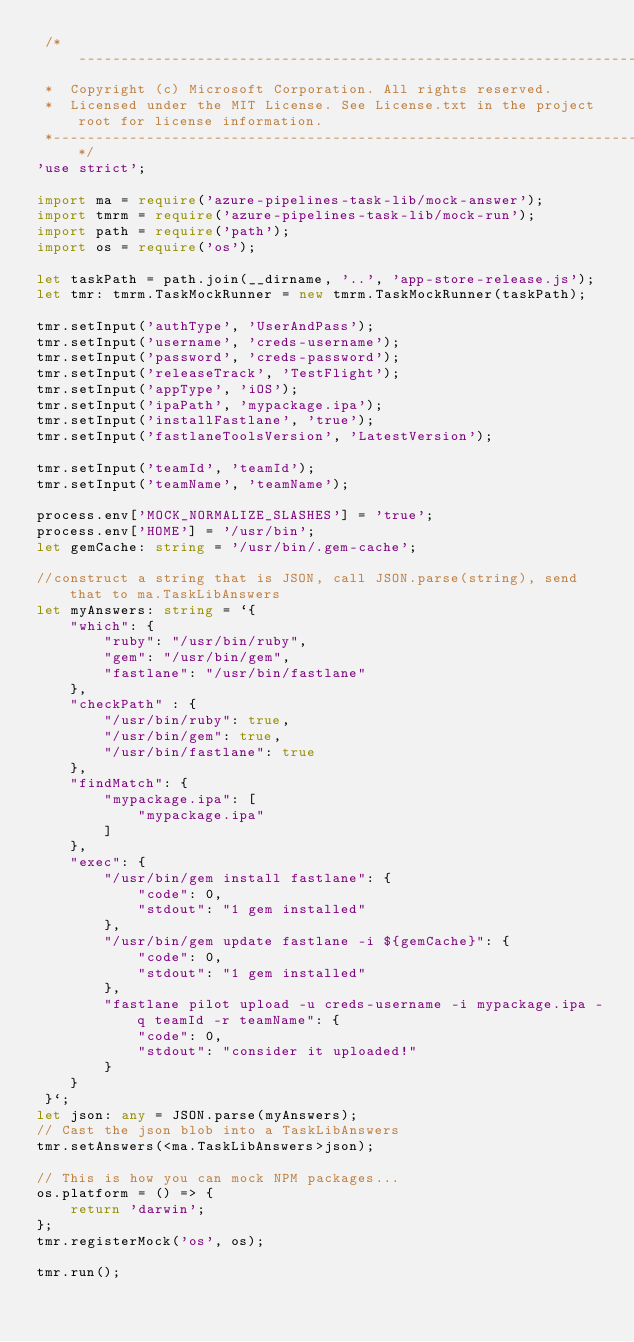<code> <loc_0><loc_0><loc_500><loc_500><_TypeScript_> /*---------------------------------------------------------------------------------------------
 *  Copyright (c) Microsoft Corporation. All rights reserved.
 *  Licensed under the MIT License. See License.txt in the project root for license information.
 *--------------------------------------------------------------------------------------------*/
'use strict';

import ma = require('azure-pipelines-task-lib/mock-answer');
import tmrm = require('azure-pipelines-task-lib/mock-run');
import path = require('path');
import os = require('os');

let taskPath = path.join(__dirname, '..', 'app-store-release.js');
let tmr: tmrm.TaskMockRunner = new tmrm.TaskMockRunner(taskPath);

tmr.setInput('authType', 'UserAndPass');
tmr.setInput('username', 'creds-username');
tmr.setInput('password', 'creds-password');
tmr.setInput('releaseTrack', 'TestFlight');
tmr.setInput('appType', 'iOS');
tmr.setInput('ipaPath', 'mypackage.ipa');
tmr.setInput('installFastlane', 'true');
tmr.setInput('fastlaneToolsVersion', 'LatestVersion');

tmr.setInput('teamId', 'teamId');
tmr.setInput('teamName', 'teamName');

process.env['MOCK_NORMALIZE_SLASHES'] = 'true';
process.env['HOME'] = '/usr/bin';
let gemCache: string = '/usr/bin/.gem-cache';

//construct a string that is JSON, call JSON.parse(string), send that to ma.TaskLibAnswers
let myAnswers: string = `{
    "which": {
        "ruby": "/usr/bin/ruby",
        "gem": "/usr/bin/gem",
        "fastlane": "/usr/bin/fastlane"
    },
    "checkPath" : {
        "/usr/bin/ruby": true,
        "/usr/bin/gem": true,
        "/usr/bin/fastlane": true
    },
    "findMatch": {
        "mypackage.ipa": [
            "mypackage.ipa"
        ]
    },
    "exec": {
        "/usr/bin/gem install fastlane": {
            "code": 0,
            "stdout": "1 gem installed"
        },
        "/usr/bin/gem update fastlane -i ${gemCache}": {
            "code": 0,
            "stdout": "1 gem installed"
        },
        "fastlane pilot upload -u creds-username -i mypackage.ipa -q teamId -r teamName": {
            "code": 0,
            "stdout": "consider it uploaded!"
        }
    }
 }`;
let json: any = JSON.parse(myAnswers);
// Cast the json blob into a TaskLibAnswers
tmr.setAnswers(<ma.TaskLibAnswers>json);

// This is how you can mock NPM packages...
os.platform = () => {
    return 'darwin';
};
tmr.registerMock('os', os);

tmr.run();
</code> 